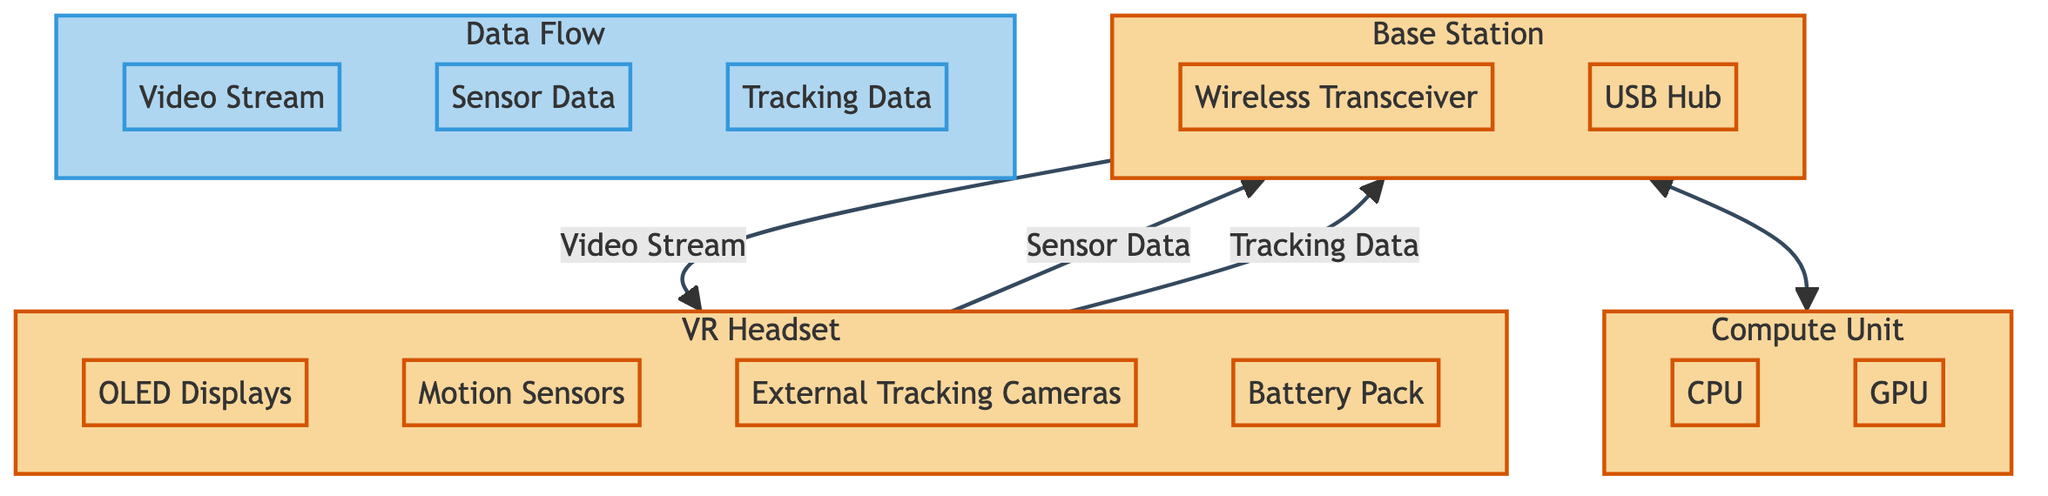What are the four main components of the VR Headset? In the diagram, the VR Headset subgraph lists four components: OLED Displays, Motion Sensors, External Tracking Cameras, and Battery Pack.
Answer: OLED Displays, Motion Sensors, External Tracking Cameras, Battery Pack How many components are in the Base Station? The Base Station subgraph has two components: Wireless Transceiver and USB Hub.
Answer: 2 What type of data flows from the VR Headset to the Base Station? The diagram shows two types of data flowing from the VR Headset to the Base Station: Sensor Data and Tracking Data.
Answer: Sensor Data, Tracking Data Which component shares data with the Compute Unit? The Base Station shares data with the Compute Unit, as indicated by the bidirectional arrow connecting them in the diagram.
Answer: Base Station How many data types are represented in the Data Flow subgraph? The Data Flow subgraph consists of three types of data: Video Stream, Sensor Data, and Tracking Data.
Answer: 3 Which hardware component in the Compute Unit is used for graphics processing? The diagram identifies the GPU as the component within the Compute Unit responsible for graphics processing.
Answer: GPU What is the relationship between the Base Station and the VR Headset regarding data flow? The Base Station and VR Headset exchange data, where the VR Headset sends Sensor Data and Tracking Data to the Base Station, and receives a Video Stream in return.
Answer: Bidirectional data exchange Which hardware component is essential for wireless communication in the system? The Wireless Transceiver in the Base Station is the essential component for enabling wireless communication within the system.
Answer: Wireless Transceiver What is the direction of the Video Stream flow in the diagram? The Video Stream flows from the Base Station to the VR Headset, as indicated by the unidirectional arrow between these components.
Answer: From Base Station to VR Headset 